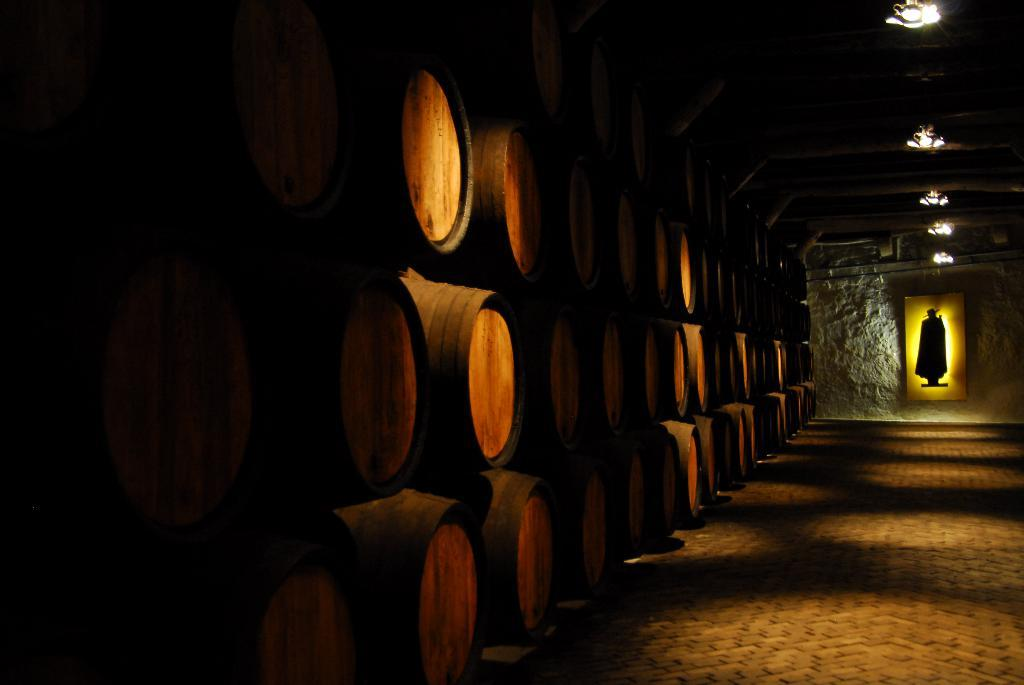What objects are present in the image? There are barrels in the image. What can be seen on the ceiling in the image? There are lights attached to the ceiling in the image. What type of distribution system is in place for the barrels in the image? There is no information about a distribution system for the barrels in the image. 